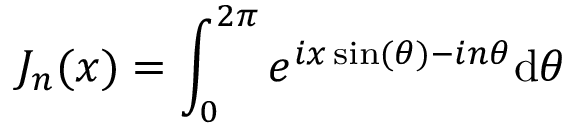<formula> <loc_0><loc_0><loc_500><loc_500>J _ { n } ( x ) = \int _ { 0 } ^ { 2 \pi } e ^ { i x \sin ( \theta ) - i n \theta } d \theta</formula> 